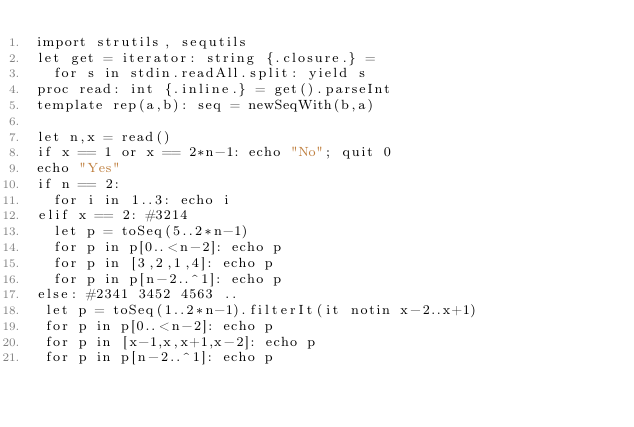Convert code to text. <code><loc_0><loc_0><loc_500><loc_500><_Nim_>import strutils, sequtils
let get = iterator: string {.closure.} =
  for s in stdin.readAll.split: yield s
proc read: int {.inline.} = get().parseInt
template rep(a,b): seq = newSeqWith(b,a)

let n,x = read()
if x == 1 or x == 2*n-1: echo "No"; quit 0
echo "Yes"
if n == 2:
  for i in 1..3: echo i
elif x == 2: #3214
  let p = toSeq(5..2*n-1)
  for p in p[0..<n-2]: echo p
  for p in [3,2,1,4]: echo p
  for p in p[n-2..^1]: echo p
else: #2341 3452 4563 ..
 let p = toSeq(1..2*n-1).filterIt(it notin x-2..x+1)
 for p in p[0..<n-2]: echo p
 for p in [x-1,x,x+1,x-2]: echo p
 for p in p[n-2..^1]: echo p
</code> 